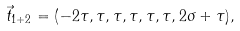Convert formula to latex. <formula><loc_0><loc_0><loc_500><loc_500>\vec { t } _ { 1 + 2 } = ( - 2 \tau , \tau , \tau , \tau , \tau , \tau , 2 \sigma + \tau ) ,</formula> 